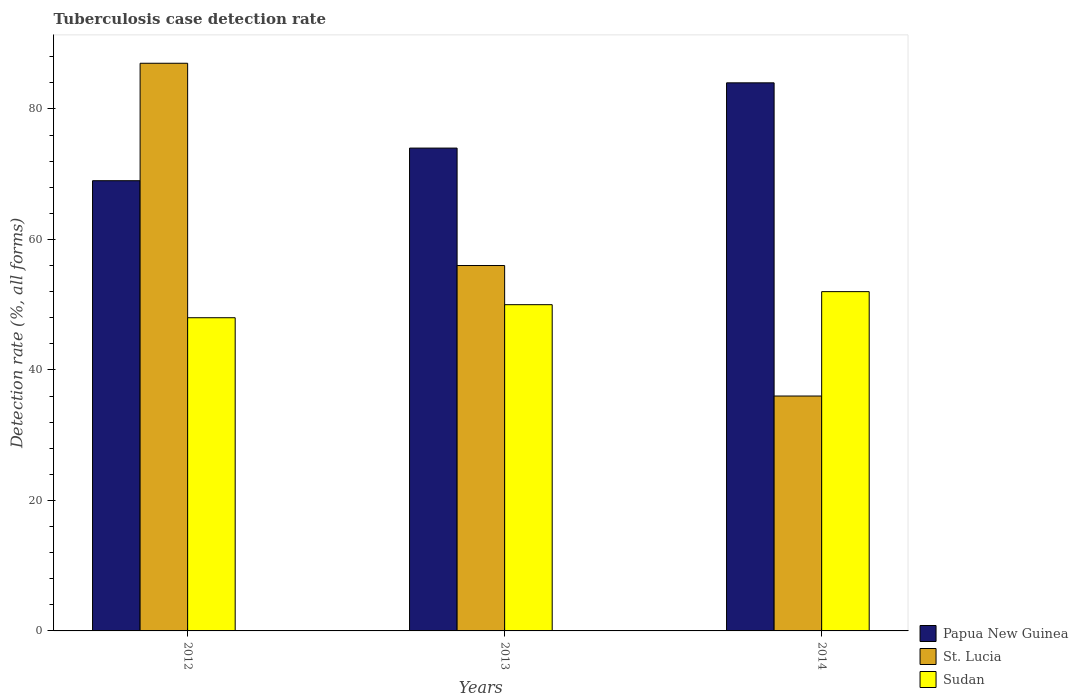Are the number of bars per tick equal to the number of legend labels?
Your response must be concise. Yes. How many bars are there on the 1st tick from the right?
Give a very brief answer. 3. What is the label of the 2nd group of bars from the left?
Make the answer very short. 2013. What is the tuberculosis case detection rate in in Papua New Guinea in 2012?
Provide a short and direct response. 69. Across all years, what is the maximum tuberculosis case detection rate in in Papua New Guinea?
Your answer should be compact. 84. Across all years, what is the minimum tuberculosis case detection rate in in Sudan?
Your answer should be compact. 48. In which year was the tuberculosis case detection rate in in Papua New Guinea minimum?
Provide a succinct answer. 2012. What is the total tuberculosis case detection rate in in Sudan in the graph?
Give a very brief answer. 150. What is the difference between the tuberculosis case detection rate in in St. Lucia in 2012 and that in 2014?
Offer a very short reply. 51. What is the difference between the tuberculosis case detection rate in in Papua New Guinea in 2012 and the tuberculosis case detection rate in in Sudan in 2013?
Your response must be concise. 19. In how many years, is the tuberculosis case detection rate in in Papua New Guinea greater than 44 %?
Your answer should be very brief. 3. What is the ratio of the tuberculosis case detection rate in in Papua New Guinea in 2013 to that in 2014?
Offer a very short reply. 0.88. Is the tuberculosis case detection rate in in Sudan in 2013 less than that in 2014?
Your answer should be very brief. Yes. Is the difference between the tuberculosis case detection rate in in Papua New Guinea in 2012 and 2013 greater than the difference between the tuberculosis case detection rate in in St. Lucia in 2012 and 2013?
Your answer should be very brief. No. What is the difference between the highest and the lowest tuberculosis case detection rate in in Papua New Guinea?
Your response must be concise. 15. What does the 3rd bar from the left in 2013 represents?
Provide a short and direct response. Sudan. What does the 1st bar from the right in 2013 represents?
Ensure brevity in your answer.  Sudan. How many bars are there?
Keep it short and to the point. 9. Are all the bars in the graph horizontal?
Your answer should be very brief. No. What is the difference between two consecutive major ticks on the Y-axis?
Your answer should be very brief. 20. Does the graph contain grids?
Give a very brief answer. No. What is the title of the graph?
Your response must be concise. Tuberculosis case detection rate. What is the label or title of the X-axis?
Provide a succinct answer. Years. What is the label or title of the Y-axis?
Provide a short and direct response. Detection rate (%, all forms). What is the Detection rate (%, all forms) in Papua New Guinea in 2012?
Your response must be concise. 69. What is the Detection rate (%, all forms) of St. Lucia in 2012?
Your answer should be compact. 87. What is the Detection rate (%, all forms) of Sudan in 2012?
Offer a terse response. 48. What is the Detection rate (%, all forms) of Papua New Guinea in 2013?
Give a very brief answer. 74. What is the Detection rate (%, all forms) of Papua New Guinea in 2014?
Ensure brevity in your answer.  84. What is the Detection rate (%, all forms) of Sudan in 2014?
Offer a terse response. 52. Across all years, what is the maximum Detection rate (%, all forms) in St. Lucia?
Make the answer very short. 87. Across all years, what is the maximum Detection rate (%, all forms) in Sudan?
Make the answer very short. 52. Across all years, what is the minimum Detection rate (%, all forms) in Papua New Guinea?
Offer a very short reply. 69. Across all years, what is the minimum Detection rate (%, all forms) in Sudan?
Give a very brief answer. 48. What is the total Detection rate (%, all forms) of Papua New Guinea in the graph?
Provide a short and direct response. 227. What is the total Detection rate (%, all forms) of St. Lucia in the graph?
Your answer should be very brief. 179. What is the total Detection rate (%, all forms) in Sudan in the graph?
Provide a succinct answer. 150. What is the difference between the Detection rate (%, all forms) in St. Lucia in 2012 and that in 2013?
Offer a very short reply. 31. What is the difference between the Detection rate (%, all forms) in Sudan in 2012 and that in 2013?
Make the answer very short. -2. What is the difference between the Detection rate (%, all forms) in Sudan in 2012 and that in 2014?
Ensure brevity in your answer.  -4. What is the difference between the Detection rate (%, all forms) in Sudan in 2013 and that in 2014?
Make the answer very short. -2. What is the difference between the Detection rate (%, all forms) of Papua New Guinea in 2012 and the Detection rate (%, all forms) of St. Lucia in 2013?
Your response must be concise. 13. What is the difference between the Detection rate (%, all forms) of Papua New Guinea in 2012 and the Detection rate (%, all forms) of Sudan in 2013?
Make the answer very short. 19. What is the difference between the Detection rate (%, all forms) of Papua New Guinea in 2012 and the Detection rate (%, all forms) of St. Lucia in 2014?
Keep it short and to the point. 33. What is the difference between the Detection rate (%, all forms) of St. Lucia in 2012 and the Detection rate (%, all forms) of Sudan in 2014?
Make the answer very short. 35. What is the difference between the Detection rate (%, all forms) of Papua New Guinea in 2013 and the Detection rate (%, all forms) of Sudan in 2014?
Your response must be concise. 22. What is the difference between the Detection rate (%, all forms) in St. Lucia in 2013 and the Detection rate (%, all forms) in Sudan in 2014?
Your answer should be compact. 4. What is the average Detection rate (%, all forms) of Papua New Guinea per year?
Offer a very short reply. 75.67. What is the average Detection rate (%, all forms) of St. Lucia per year?
Your answer should be very brief. 59.67. What is the average Detection rate (%, all forms) in Sudan per year?
Your answer should be compact. 50. In the year 2013, what is the difference between the Detection rate (%, all forms) of Papua New Guinea and Detection rate (%, all forms) of St. Lucia?
Make the answer very short. 18. In the year 2013, what is the difference between the Detection rate (%, all forms) of St. Lucia and Detection rate (%, all forms) of Sudan?
Give a very brief answer. 6. In the year 2014, what is the difference between the Detection rate (%, all forms) of Papua New Guinea and Detection rate (%, all forms) of St. Lucia?
Provide a succinct answer. 48. What is the ratio of the Detection rate (%, all forms) in Papua New Guinea in 2012 to that in 2013?
Give a very brief answer. 0.93. What is the ratio of the Detection rate (%, all forms) in St. Lucia in 2012 to that in 2013?
Your answer should be compact. 1.55. What is the ratio of the Detection rate (%, all forms) of Sudan in 2012 to that in 2013?
Your answer should be very brief. 0.96. What is the ratio of the Detection rate (%, all forms) in Papua New Guinea in 2012 to that in 2014?
Ensure brevity in your answer.  0.82. What is the ratio of the Detection rate (%, all forms) in St. Lucia in 2012 to that in 2014?
Give a very brief answer. 2.42. What is the ratio of the Detection rate (%, all forms) in Papua New Guinea in 2013 to that in 2014?
Keep it short and to the point. 0.88. What is the ratio of the Detection rate (%, all forms) in St. Lucia in 2013 to that in 2014?
Provide a short and direct response. 1.56. What is the ratio of the Detection rate (%, all forms) of Sudan in 2013 to that in 2014?
Offer a very short reply. 0.96. What is the difference between the highest and the second highest Detection rate (%, all forms) of Papua New Guinea?
Make the answer very short. 10. What is the difference between the highest and the lowest Detection rate (%, all forms) in St. Lucia?
Keep it short and to the point. 51. 